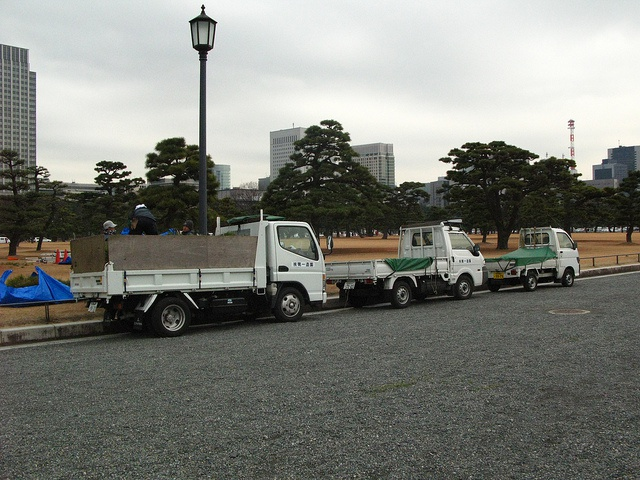Describe the objects in this image and their specific colors. I can see truck in lightgray, gray, darkgray, and black tones, truck in lightgray, black, darkgray, and gray tones, truck in lightgray, black, gray, darkgray, and darkgreen tones, people in lightgray, black, purple, and darkblue tones, and people in lightgray, black, gray, darkgray, and maroon tones in this image. 